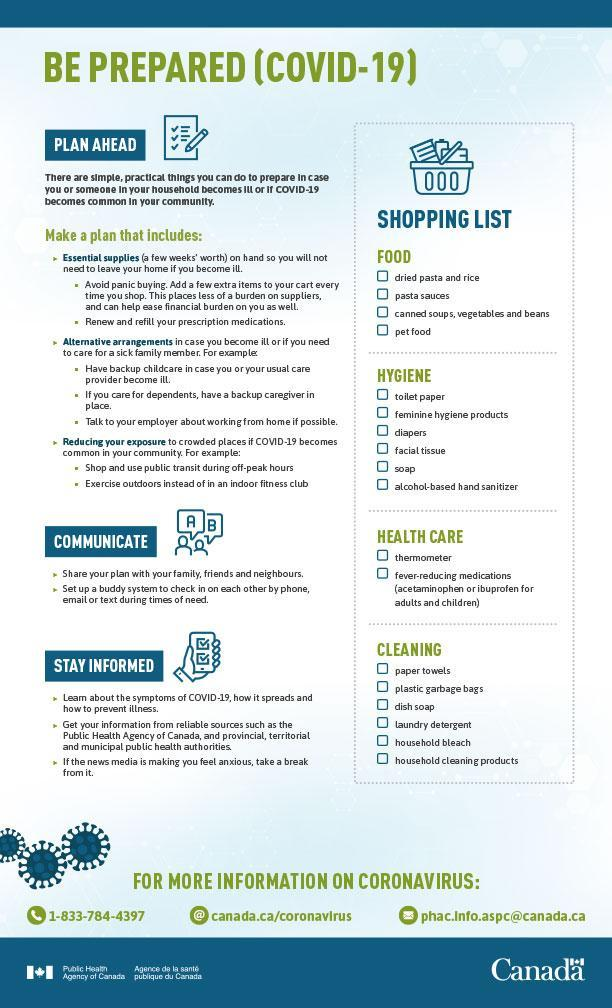What is the sixth item in the hygiene shopping list?
Answer the question with a short phrase. alcohol-based hand sanitizer What are the medicines for pain and fever that are mentioned in the list? acetaminophen, ibuprofen In which section of the shopping list are only 2 items listed? health care Dish soap is included in which section of the shopping list? cleaning How many items listed under Food in the shopping list? 4 What are the third and fourth items in the hygiene shopping list? diapers, facial tissue What is the second item in the food shopping list? pasta sauces What is the second item in the cleaning section of shopping list? plastic garbage bags 